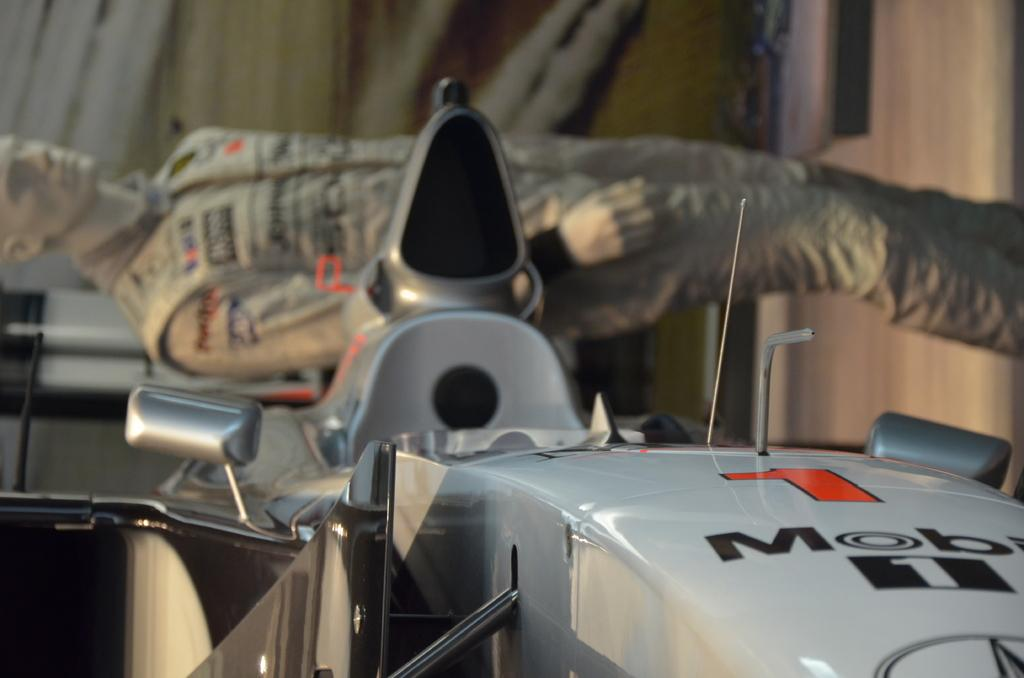What is the main subject in the image? There is a vehicle in the image. What other notable object can be seen in the image? There is a statue in the image. Can you describe the background of the image? There are objects in the background of the image. How much money is being exchanged between the vehicle and the statue in the image? There is no indication of any money exchange between the vehicle and the statue in the image. What type of record is being played by the vehicle in the image? There is no record or any indication of music or sound in the image. 